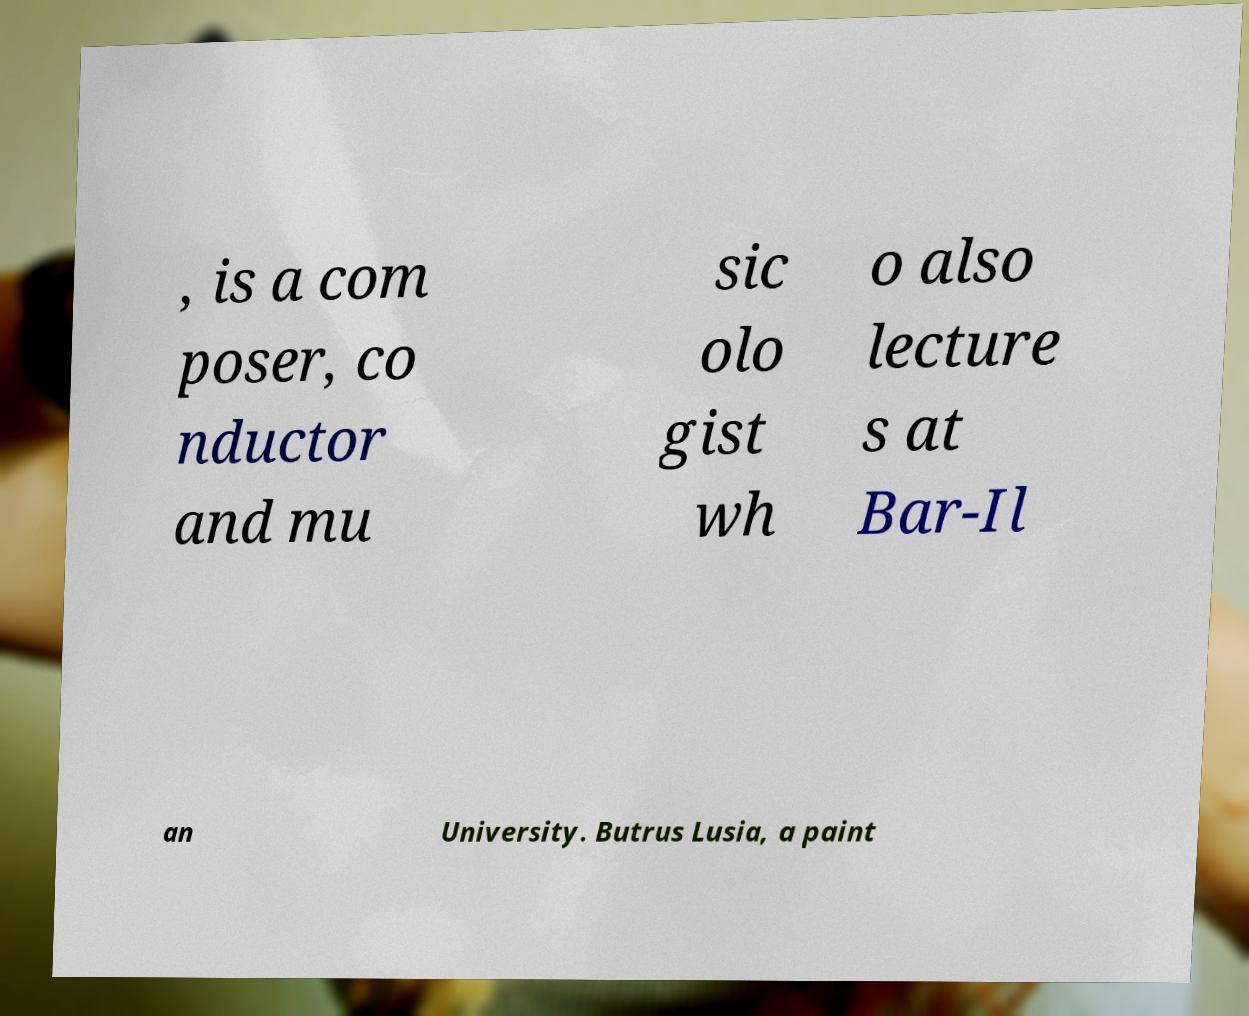Please read and relay the text visible in this image. What does it say? , is a com poser, co nductor and mu sic olo gist wh o also lecture s at Bar-Il an University. Butrus Lusia, a paint 